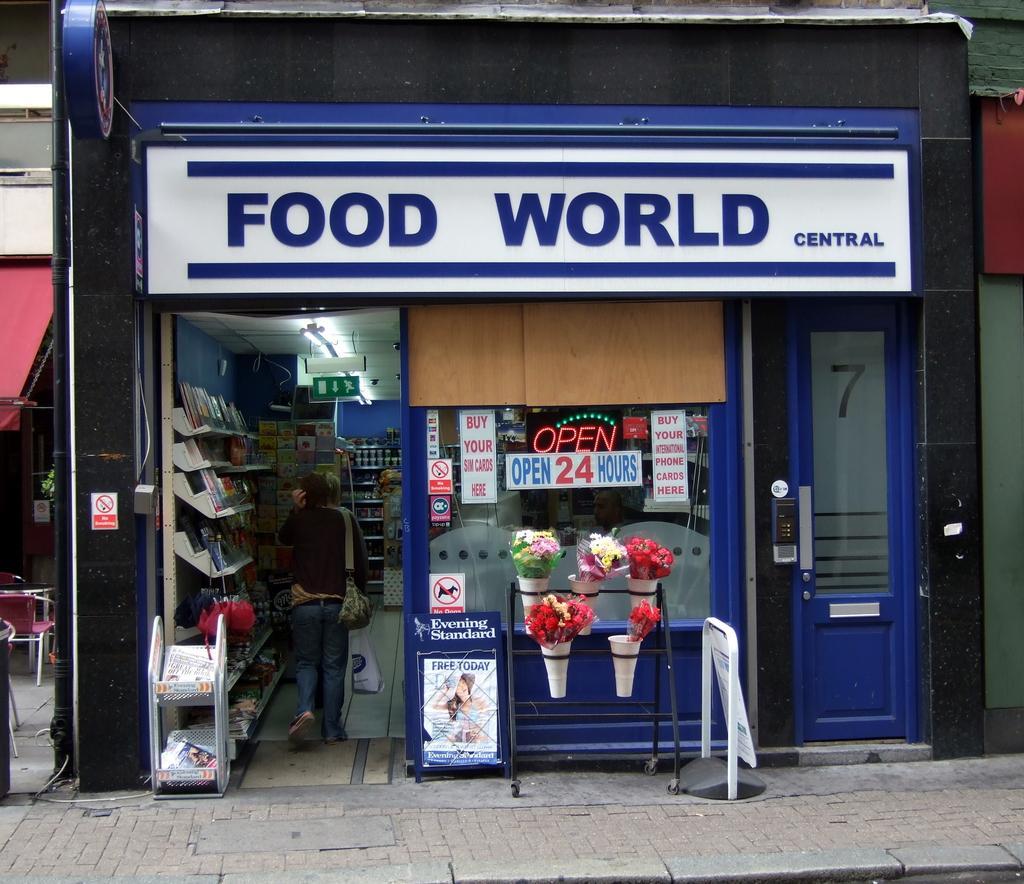Can you describe this image briefly? This picture consists of shop, inside of shop there is a person and rack , there are books visible in the rack , in front of shop a stand visible and flower, bookey kept on it, on the wall of the shop there is a board , on board there is a text visible, on the left side I can see a tent and I can see a chair. 